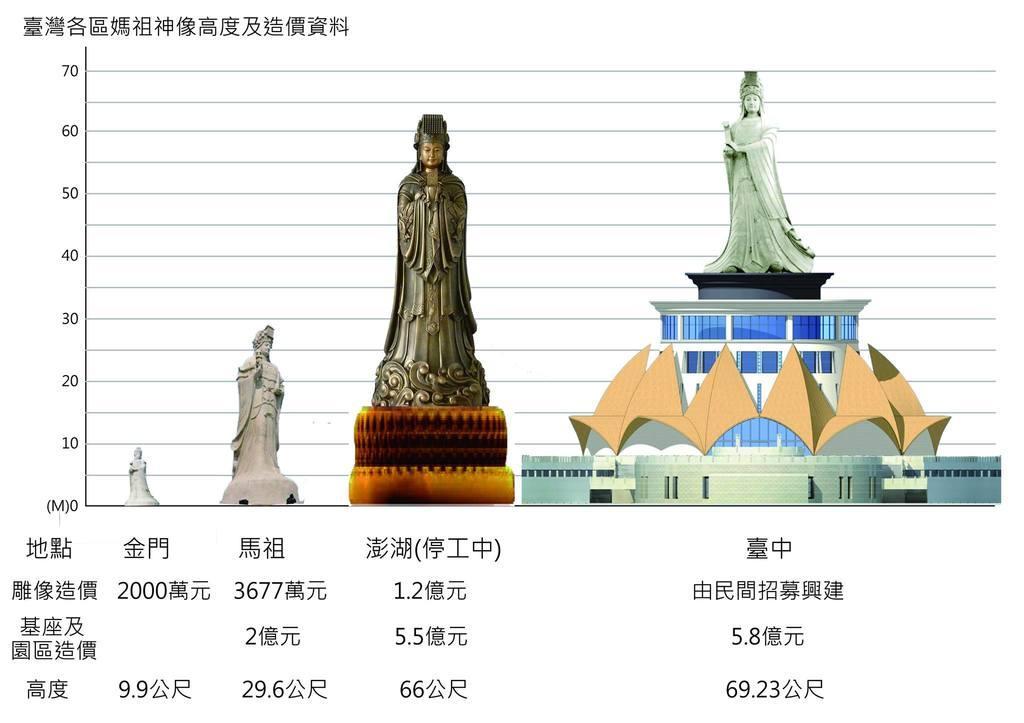In one or two sentences, can you explain what this image depicts? In this image I can see the paper. In the paper I can see the statues. I can see one statue is on the building. And I can see something is written on it. 